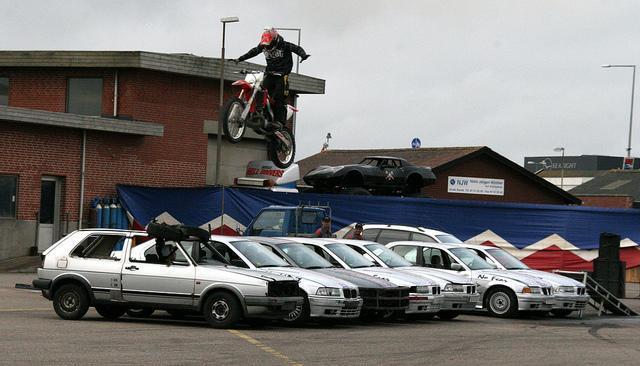Why is he in midair?
Select the correct answer and articulate reasoning with the following format: 'Answer: answer
Rationale: rationale.'
Options: Broken wheells, showing off, he fell, bounced there. Answer: showing off.
Rationale: The man is trying to show off his skills. 